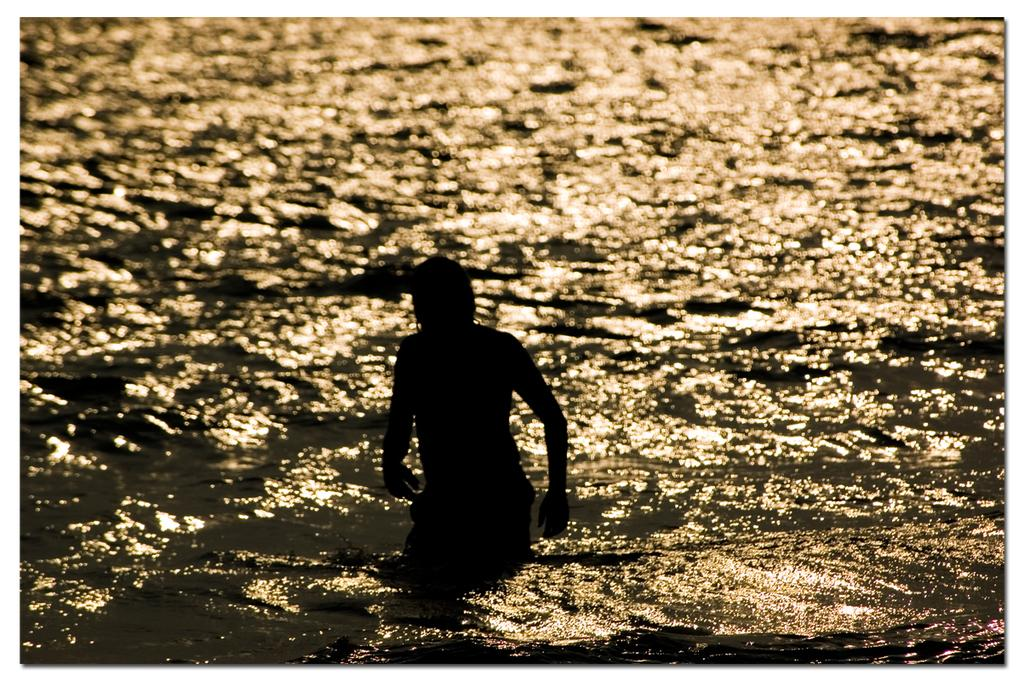What is visible in the image? There is water and a person visible in the image. Can you describe the person in the image? Unfortunately, the facts provided do not give any details about the person's appearance or actions. What is the primary setting of the image? The primary setting of the image is water. What type of hook can be seen in the image? There is no hook present in the image. Is the person in the image at a hospital? The facts provided do not give any information about the location or context of the image, so we cannot determine if the person is at a hospital. 